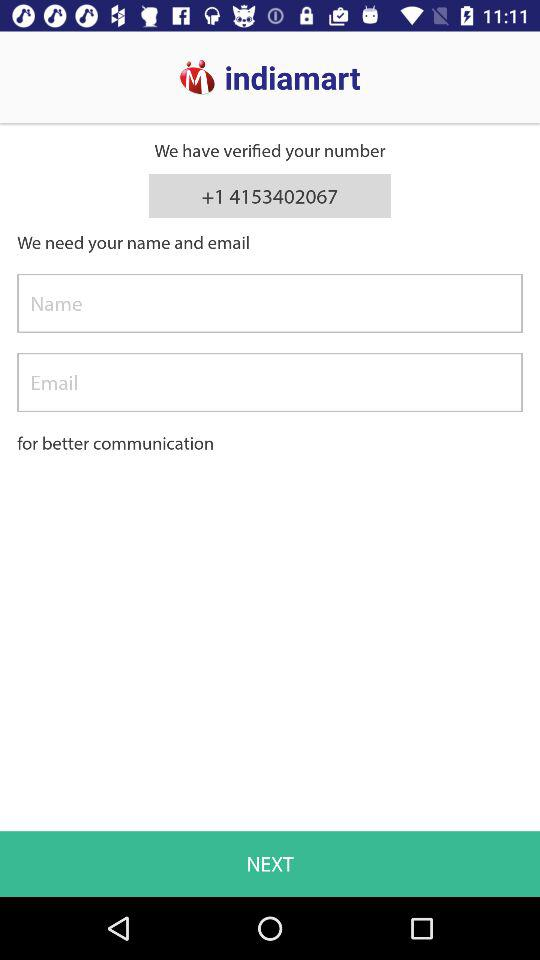How many input fields are there for providing contact information?
Answer the question using a single word or phrase. 2 